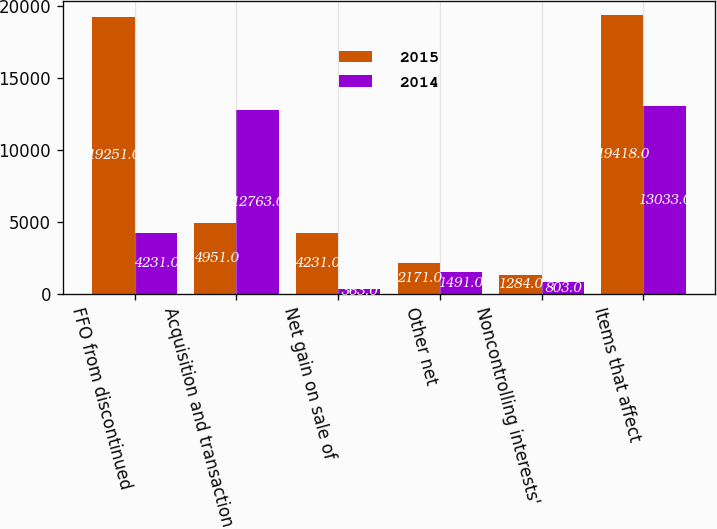Convert chart. <chart><loc_0><loc_0><loc_500><loc_500><stacked_bar_chart><ecel><fcel>FFO from discontinued<fcel>Acquisition and transaction<fcel>Net gain on sale of<fcel>Other net<fcel>Noncontrolling interests'<fcel>Items that affect<nl><fcel>2015<fcel>19251<fcel>4951<fcel>4231<fcel>2171<fcel>1284<fcel>19418<nl><fcel>2014<fcel>4231<fcel>12763<fcel>363<fcel>1491<fcel>803<fcel>13033<nl></chart> 